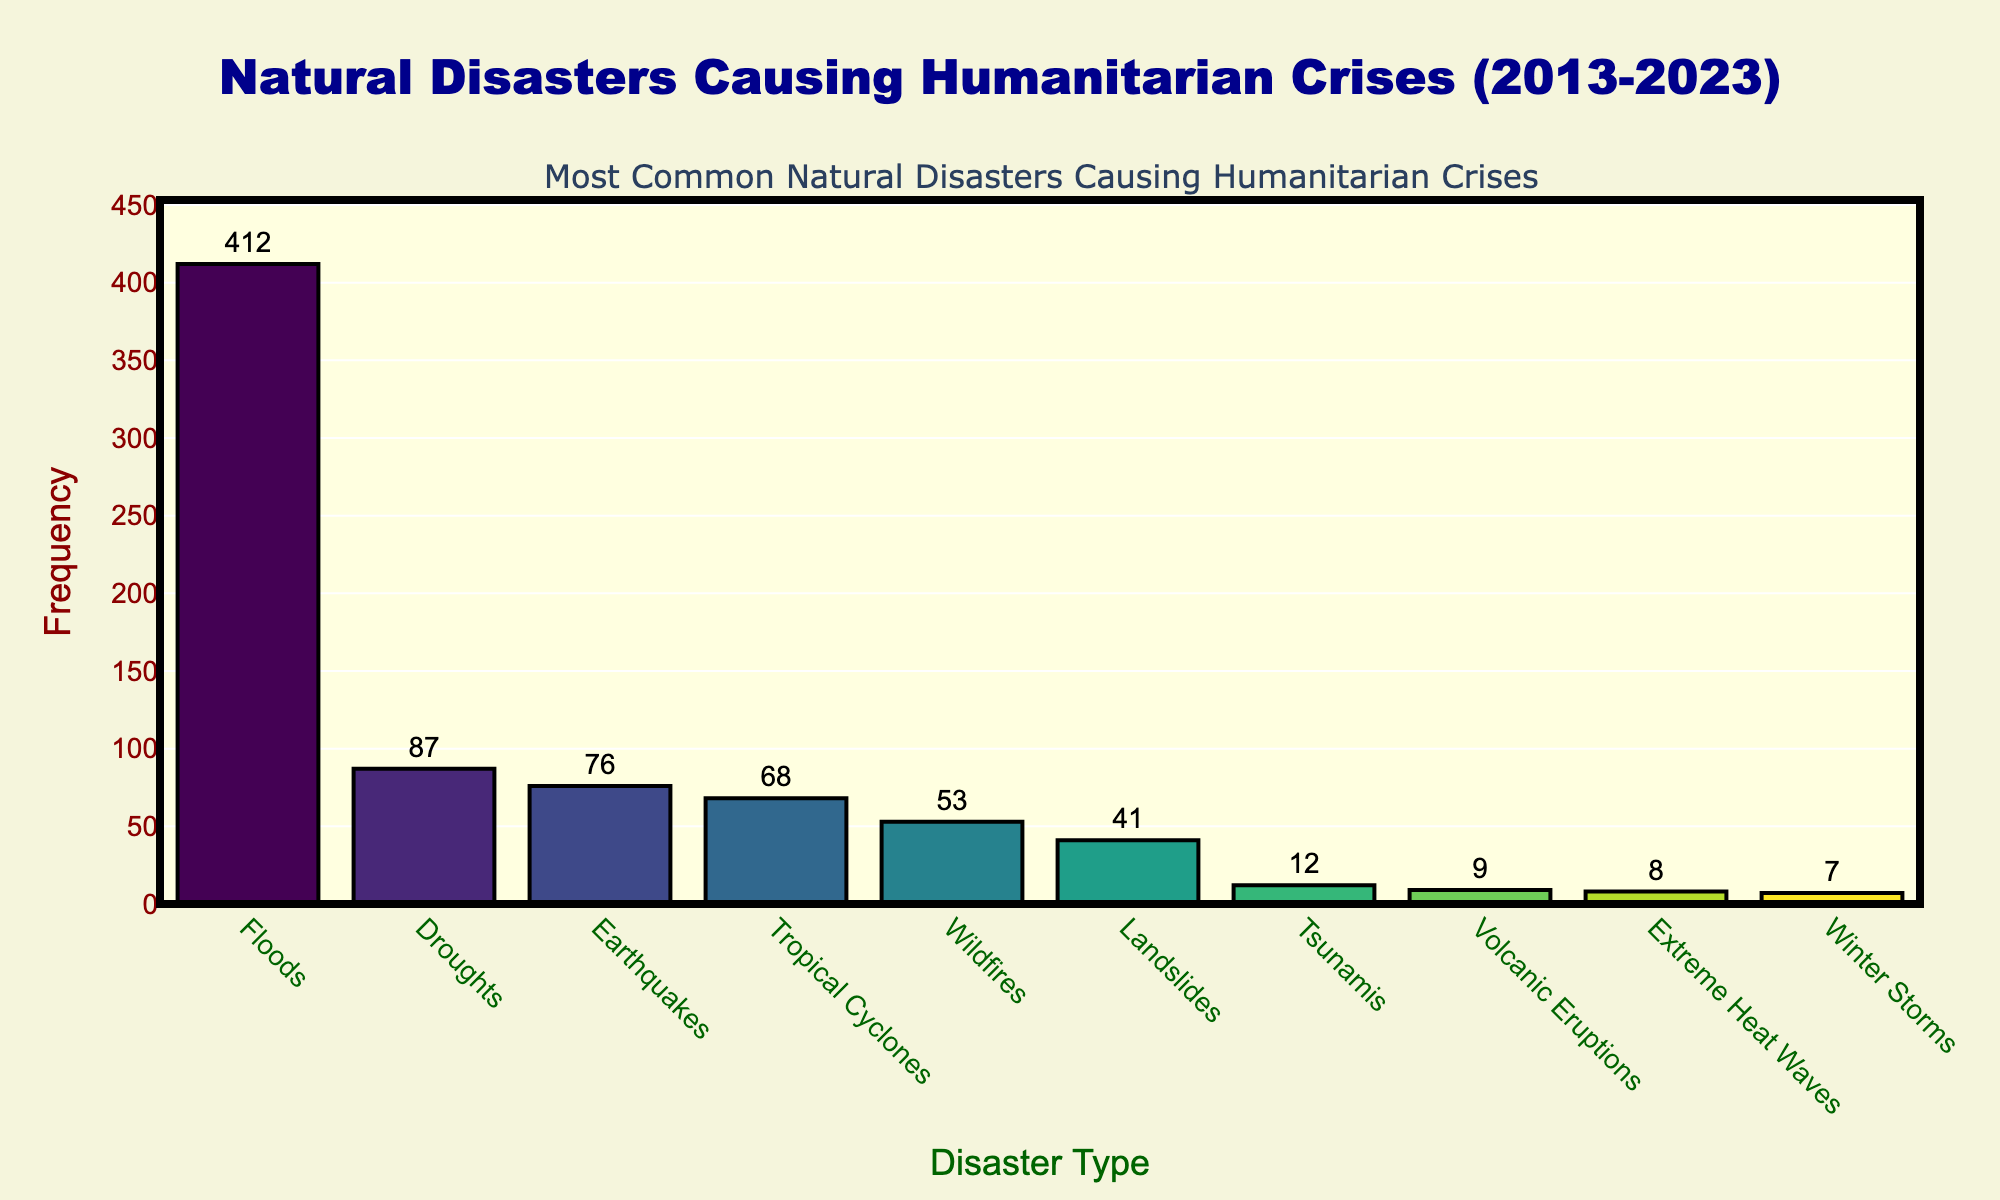What type of natural disaster is the most common from 2013 to 2023? From the chart, we see that the highest bar represents floods, meaning floods have the highest frequency.
Answer: Floods How many more floods than droughts were there from 2013 to 2023? The frequency of floods is 412, and the frequency of droughts is 87. The difference is 412 - 87.
Answer: 325 Which natural disaster has the lowest frequency? The bar representing winter storms has the shortest height, indicating it has the lowest frequency.
Answer: Winter Storms What is the combined frequency of earthquakes and tropical cyclones? The frequency of earthquakes is 76, and the frequency of tropical cyclones is 68. Adding these together gives 76 + 68.
Answer: 144 Is the frequency of wildfires higher or lower than that of landslides? The bar for wildfires is taller than the bar for landslides, indicating the frequency is higher for wildfires.
Answer: Higher What is the difference in frequency between tsunamis and volcanic eruptions? Tsunamis have a frequency of 12, while volcanic eruptions have a frequency of 9. The difference is 12 - 9.
Answer: 3 How does the frequency of extreme heat waves compare to that of winter storms? The frequency of extreme heat waves is 8, while winter storms have a frequency of 7. Comparing 8 to 7 shows that extreme heat waves occur more frequently.
Answer: More frequently If you add the frequencies of the three least common disasters, what is the total? The frequencies for the three least common disasters (volcanic eruptions, extreme heat waves, winter storms) are 9, 8, and 7, respectively. Adding these gives 9 + 8 + 7.
Answer: 24 Which disaster type has a frequency closest to 50? Wildfires have a frequency of 53, which is the closest to 50 among all the disaster types.
Answer: Wildfires 